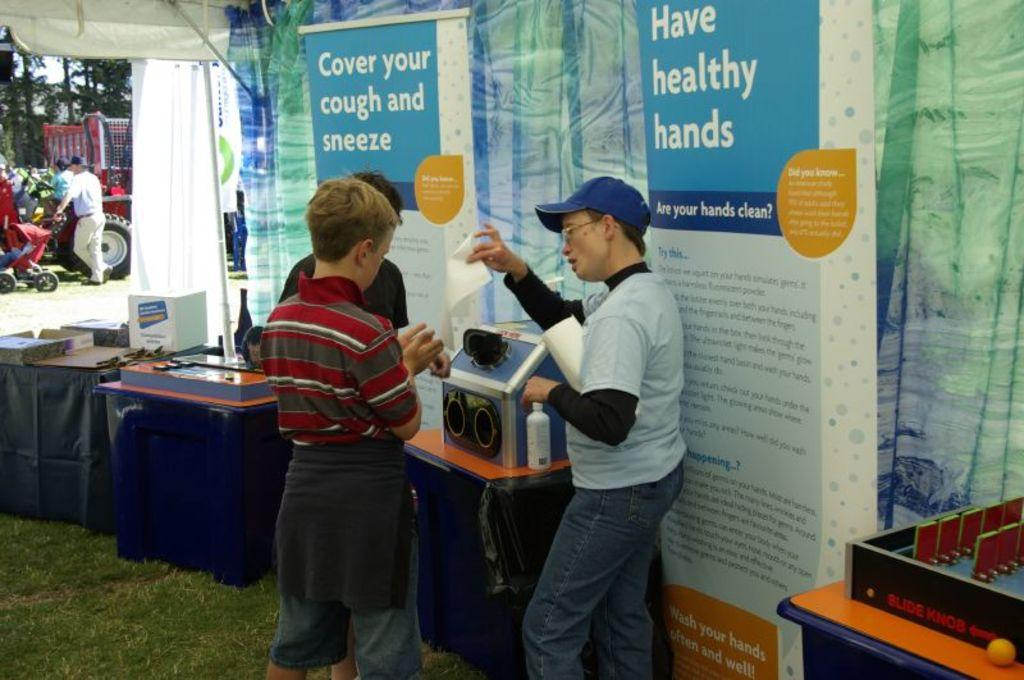Provide a one-sentence caption for the provided image. A person handing out flyers promoting the practice to cover your cough and sneeze and have healthy hands. 